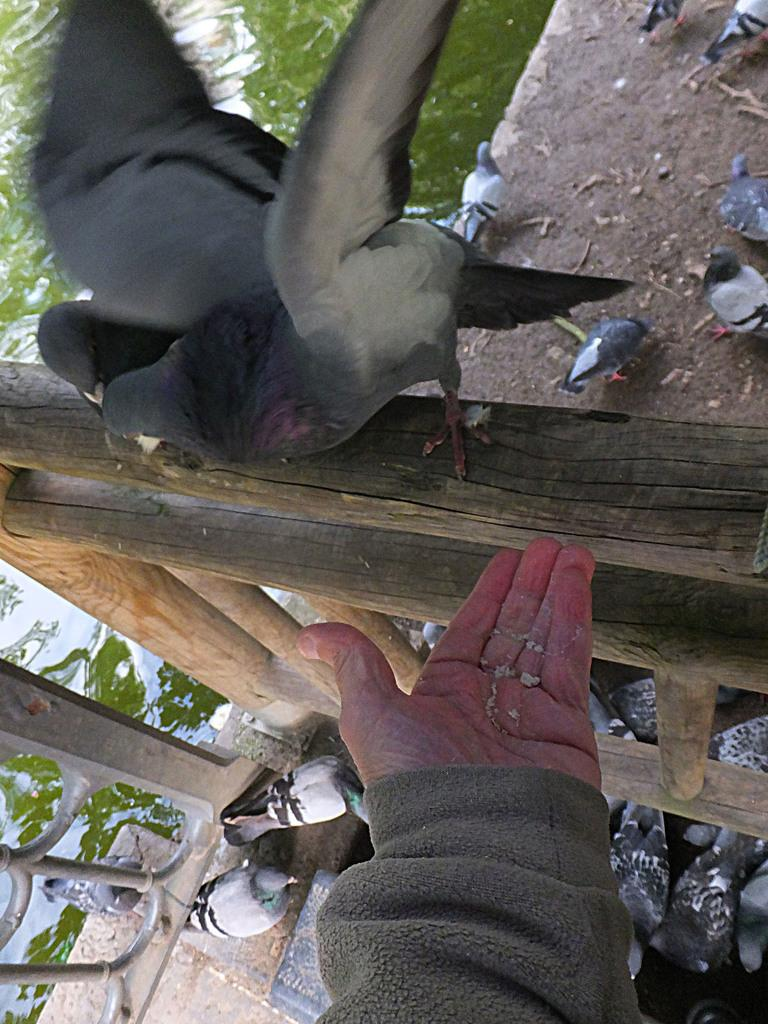What type of animals can be seen in the image? Birds can be seen in the image. What is the primary element in which the birds are situated? The birds are situated in water. Can you describe the person's hand in the image? A person's hand is present in the image, but its specific action or context is not clear. Where are the birds located on the wooden fencing? The birds are on the wooden fencing in the image. What type of reward is the person receiving for building the houses in the image? There are no houses or rewards present in the image; it features birds in water and a person's hand near wooden fencing. 